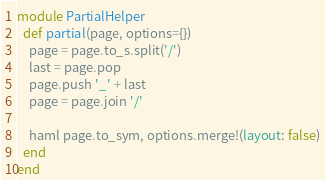Convert code to text. <code><loc_0><loc_0><loc_500><loc_500><_Ruby_>module PartialHelper
  def partial(page, options={})
    page = page.to_s.split('/')
    last = page.pop
    page.push '_' + last
    page = page.join '/'

    haml page.to_sym, options.merge!(layout: false)
  end
end
</code> 